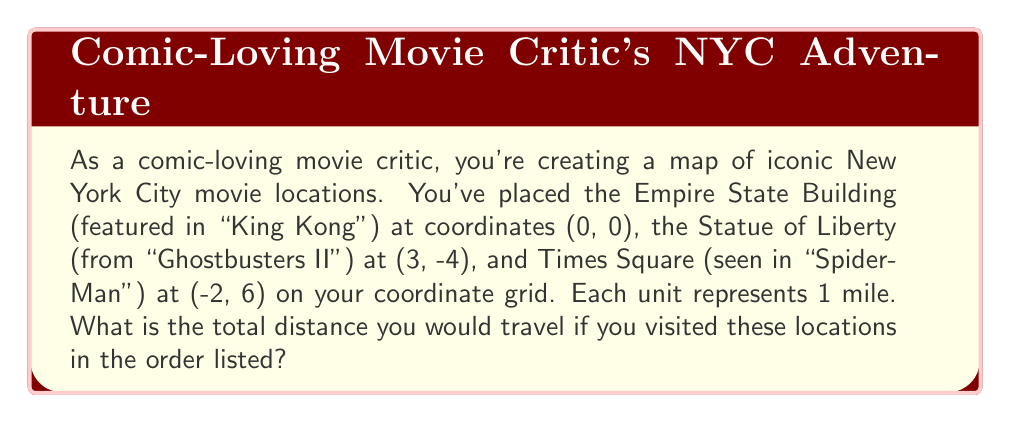Show me your answer to this math problem. To solve this problem, we need to calculate the distances between each pair of locations and then sum them up. We'll use the distance formula between two points $(x_1, y_1)$ and $(x_2, y_2)$:

$$d = \sqrt{(x_2 - x_1)^2 + (y_2 - y_1)^2}$$

1. Distance from Empire State Building (0, 0) to Statue of Liberty (3, -4):
   $$d_1 = \sqrt{(3 - 0)^2 + (-4 - 0)^2} = \sqrt{9 + 16} = \sqrt{25} = 5\text{ miles}$$

2. Distance from Statue of Liberty (3, -4) to Times Square (-2, 6):
   $$d_2 = \sqrt{(-2 - 3)^2 + (6 - (-4))^2} = \sqrt{(-5)^2 + 10^2} = \sqrt{25 + 100} = \sqrt{125} = 5\sqrt{5}\text{ miles}$$

3. Total distance:
   $$\text{Total} = d_1 + d_2 = 5 + 5\sqrt{5}\text{ miles}$$

[asy]
unitsize(1cm);
dot((0,0));
dot((3,-4));
dot((-2,6));
label("Empire State Building (0,0)", (0,0), SE);
label("Statue of Liberty (3,-4)", (3,-4), SE);
label("Times Square (-2,6)", (-2,6), NW);
draw((0,0)--(3,-4)--(-2,6), arrow=Arrow(TeXHead));
[/asy]
Answer: $5 + 5\sqrt{5}$ miles 